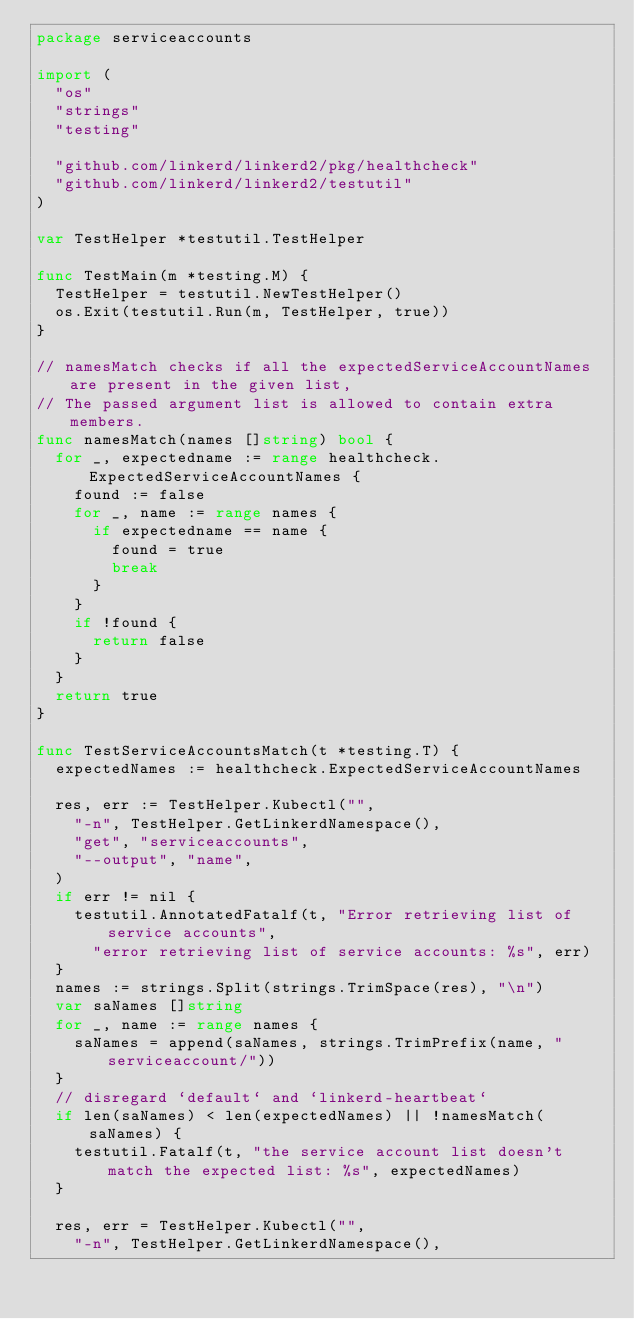<code> <loc_0><loc_0><loc_500><loc_500><_Go_>package serviceaccounts

import (
	"os"
	"strings"
	"testing"

	"github.com/linkerd/linkerd2/pkg/healthcheck"
	"github.com/linkerd/linkerd2/testutil"
)

var TestHelper *testutil.TestHelper

func TestMain(m *testing.M) {
	TestHelper = testutil.NewTestHelper()
	os.Exit(testutil.Run(m, TestHelper, true))
}

// namesMatch checks if all the expectedServiceAccountNames are present in the given list,
// The passed argument list is allowed to contain extra members.
func namesMatch(names []string) bool {
	for _, expectedname := range healthcheck.ExpectedServiceAccountNames {
		found := false
		for _, name := range names {
			if expectedname == name {
				found = true
				break
			}
		}
		if !found {
			return false
		}
	}
	return true
}

func TestServiceAccountsMatch(t *testing.T) {
	expectedNames := healthcheck.ExpectedServiceAccountNames

	res, err := TestHelper.Kubectl("",
		"-n", TestHelper.GetLinkerdNamespace(),
		"get", "serviceaccounts",
		"--output", "name",
	)
	if err != nil {
		testutil.AnnotatedFatalf(t, "Error retrieving list of service accounts",
			"error retrieving list of service accounts: %s", err)
	}
	names := strings.Split(strings.TrimSpace(res), "\n")
	var saNames []string
	for _, name := range names {
		saNames = append(saNames, strings.TrimPrefix(name, "serviceaccount/"))
	}
	// disregard `default` and `linkerd-heartbeat`
	if len(saNames) < len(expectedNames) || !namesMatch(saNames) {
		testutil.Fatalf(t, "the service account list doesn't match the expected list: %s", expectedNames)
	}

	res, err = TestHelper.Kubectl("",
		"-n", TestHelper.GetLinkerdNamespace(),</code> 